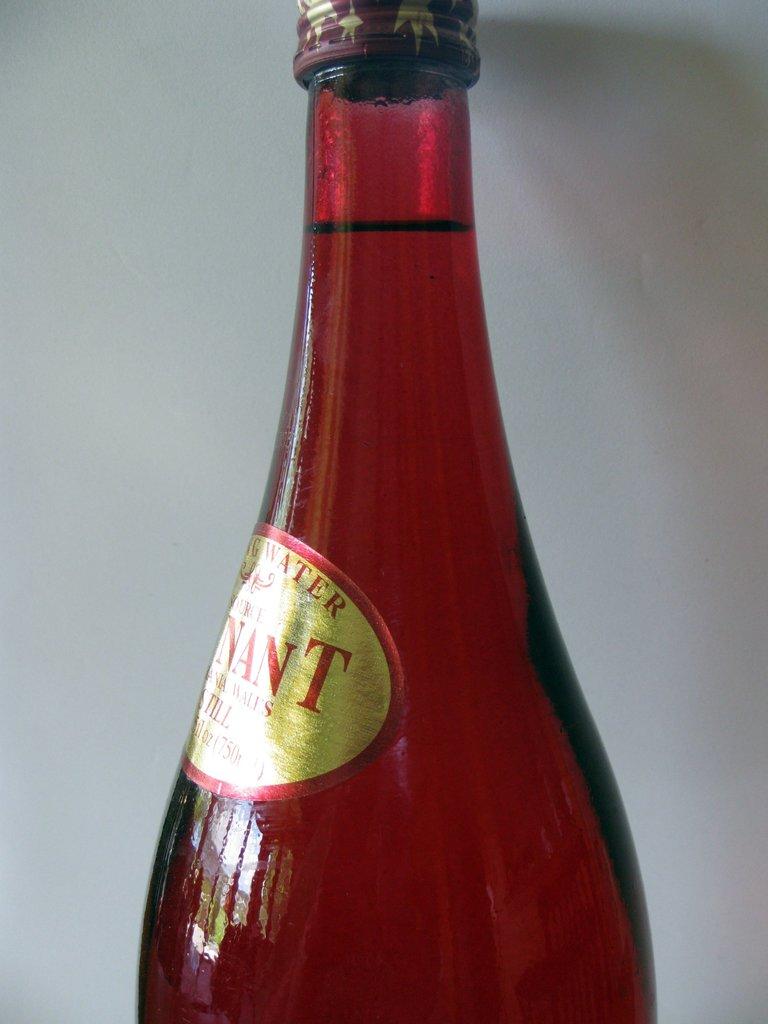What is the last red letter on the label?
Make the answer very short. T. What is the name on the bottle?
Offer a terse response. Unanswerable. 